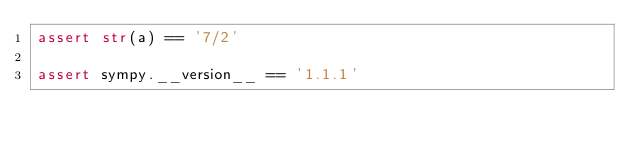Convert code to text. <code><loc_0><loc_0><loc_500><loc_500><_Python_>assert str(a) == '7/2'

assert sympy.__version__ == '1.1.1'
</code> 